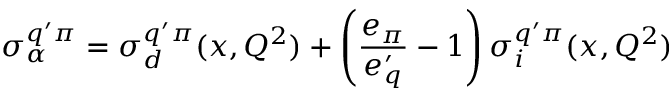Convert formula to latex. <formula><loc_0><loc_0><loc_500><loc_500>\sigma _ { \alpha } ^ { q ^ { \prime } \pi } = \sigma _ { d } ^ { q ^ { \prime } \pi } ( x , Q ^ { 2 } ) + \left ( \frac { e _ { \pi } } { e _ { q } ^ { \prime } } - 1 \right ) \sigma _ { i } ^ { q ^ { \prime } \pi } ( x , Q ^ { 2 } )</formula> 